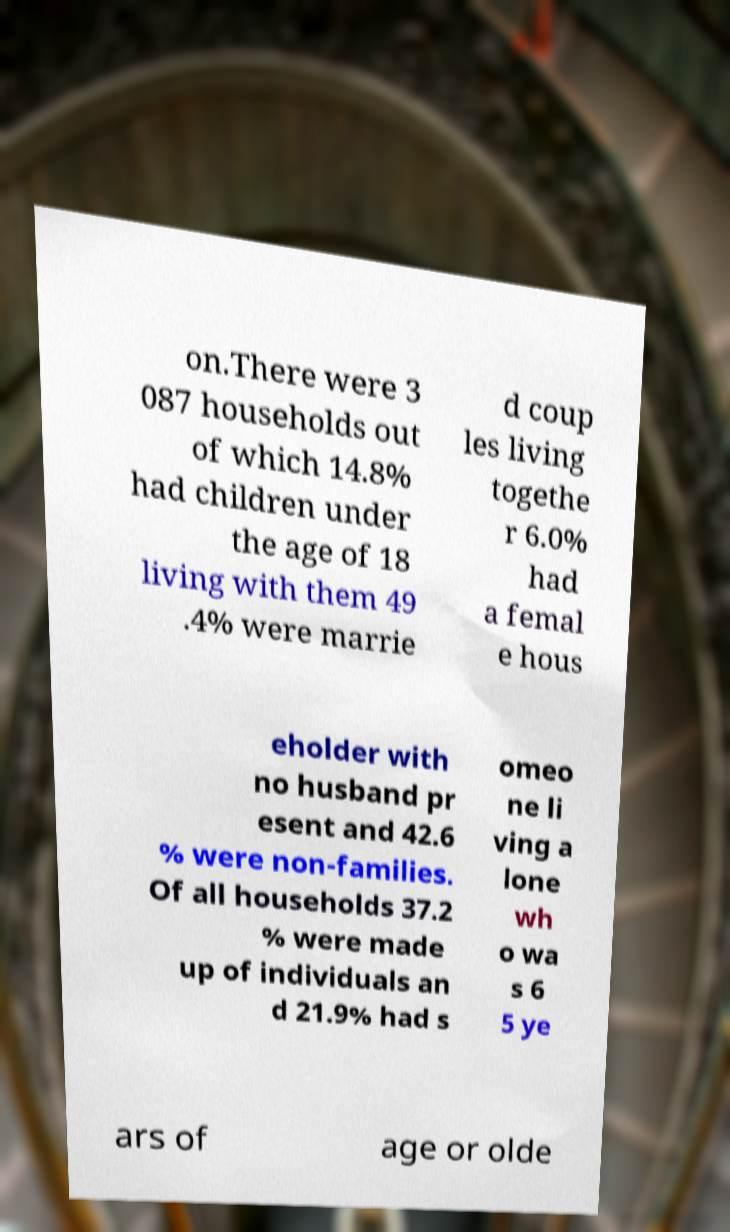Could you assist in decoding the text presented in this image and type it out clearly? on.There were 3 087 households out of which 14.8% had children under the age of 18 living with them 49 .4% were marrie d coup les living togethe r 6.0% had a femal e hous eholder with no husband pr esent and 42.6 % were non-families. Of all households 37.2 % were made up of individuals an d 21.9% had s omeo ne li ving a lone wh o wa s 6 5 ye ars of age or olde 